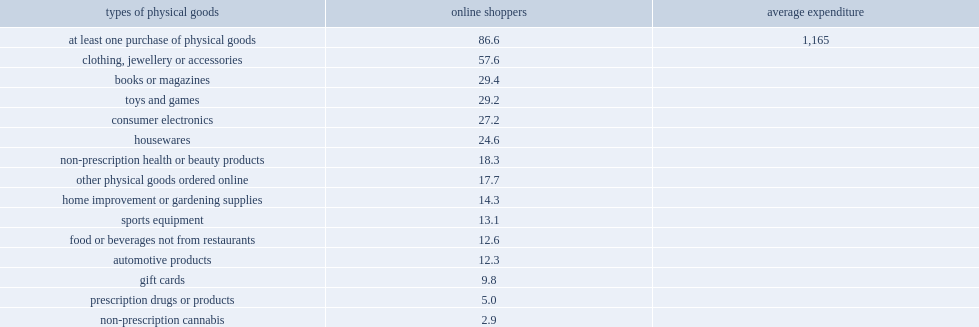What percent of physical goods were ordered over the internet and delivered or picked up? 86.6. Which type of physical goods is the most frequent type of online purchase among online shoppers? At least one purchase of physical goods. What average expenditure did internet users who reported buying physical goods spend on the goods they purchased? 1165. Parse the table in full. {'header': ['types of physical goods', 'online shoppers', 'average expenditure'], 'rows': [['at least one purchase of physical goods', '86.6', '1,165'], ['clothing, jewellery or accessories', '57.6', ''], ['books or magazines', '29.4', ''], ['toys and games', '29.2', ''], ['consumer electronics', '27.2', ''], ['housewares', '24.6', ''], ['non-prescription health or beauty products', '18.3', ''], ['other physical goods ordered online', '17.7', ''], ['home improvement or gardening supplies', '14.3', ''], ['sports equipment', '13.1', ''], ['food or beverages not from restaurants', '12.6', ''], ['automotive products', '12.3', ''], ['gift cards', '9.8', ''], ['prescription drugs or products', '5.0', ''], ['non-prescription cannabis', '2.9', '']]} 